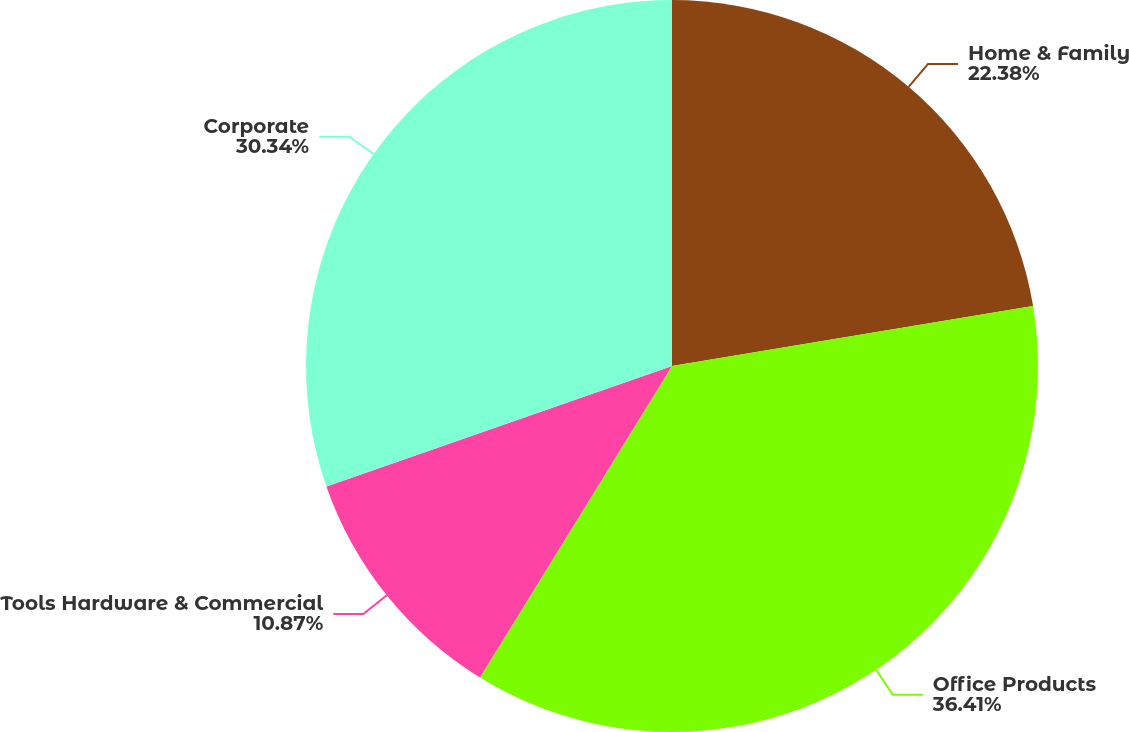Convert chart. <chart><loc_0><loc_0><loc_500><loc_500><pie_chart><fcel>Home & Family<fcel>Office Products<fcel>Tools Hardware & Commercial<fcel>Corporate<nl><fcel>22.38%<fcel>36.41%<fcel>10.87%<fcel>30.34%<nl></chart> 